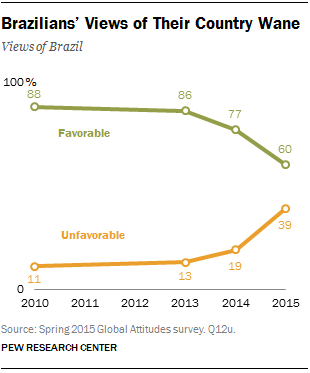Identify some key points in this picture. The line that contains smaller values across all years is "Unfavorable. The most unfavorable view is deducted from the most favorable view, resulting in a total of 49. 